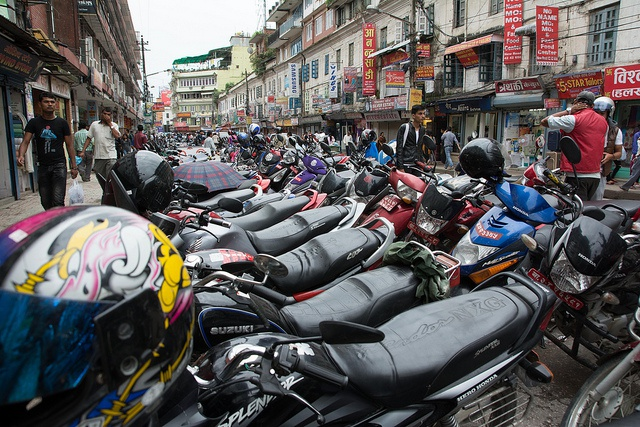Describe the objects in this image and their specific colors. I can see motorcycle in green, black, darkgray, gray, and lightgray tones, motorcycle in green, black, gray, darkgray, and maroon tones, motorcycle in green, black, darkgray, gray, and white tones, motorcycle in green, black, darkgray, gray, and lightgray tones, and motorcycle in green, black, blue, navy, and darkgray tones in this image. 